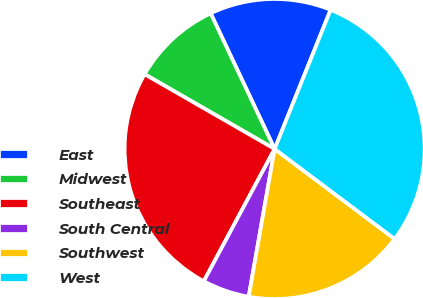Convert chart. <chart><loc_0><loc_0><loc_500><loc_500><pie_chart><fcel>East<fcel>Midwest<fcel>Southeast<fcel>South Central<fcel>Southwest<fcel>West<nl><fcel>13.1%<fcel>9.68%<fcel>25.48%<fcel>5.06%<fcel>17.53%<fcel>29.15%<nl></chart> 